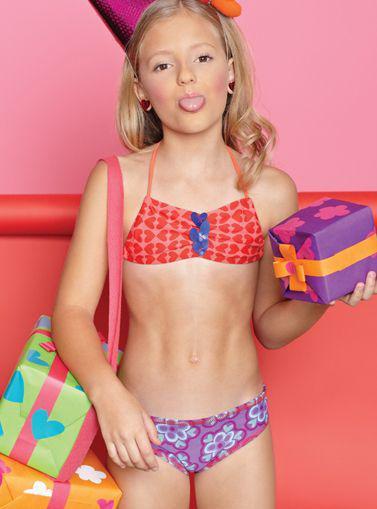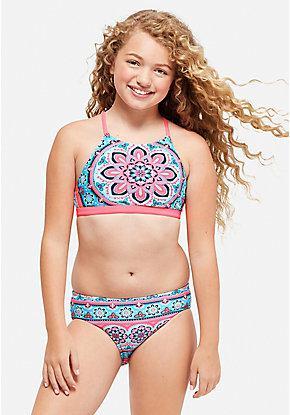The first image is the image on the left, the second image is the image on the right. For the images displayed, is the sentence "A girl is laying down in colorful hearts" factually correct? Answer yes or no. No. 